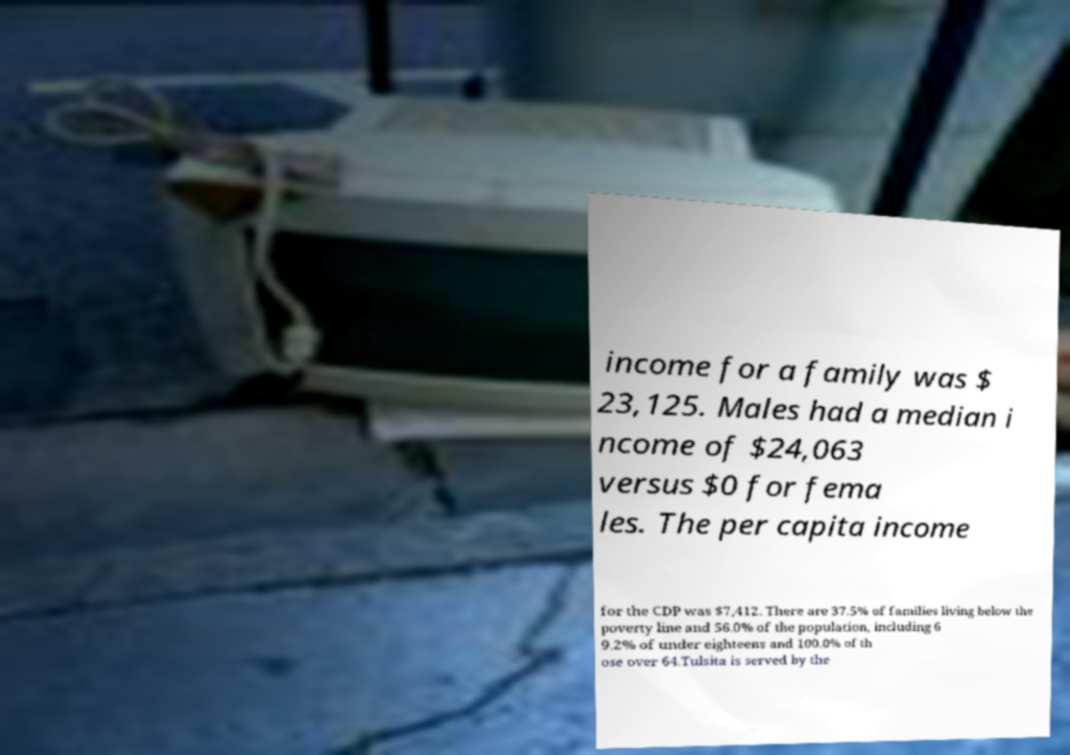What messages or text are displayed in this image? I need them in a readable, typed format. income for a family was $ 23,125. Males had a median i ncome of $24,063 versus $0 for fema les. The per capita income for the CDP was $7,412. There are 37.5% of families living below the poverty line and 56.0% of the population, including 6 9.2% of under eighteens and 100.0% of th ose over 64.Tulsita is served by the 